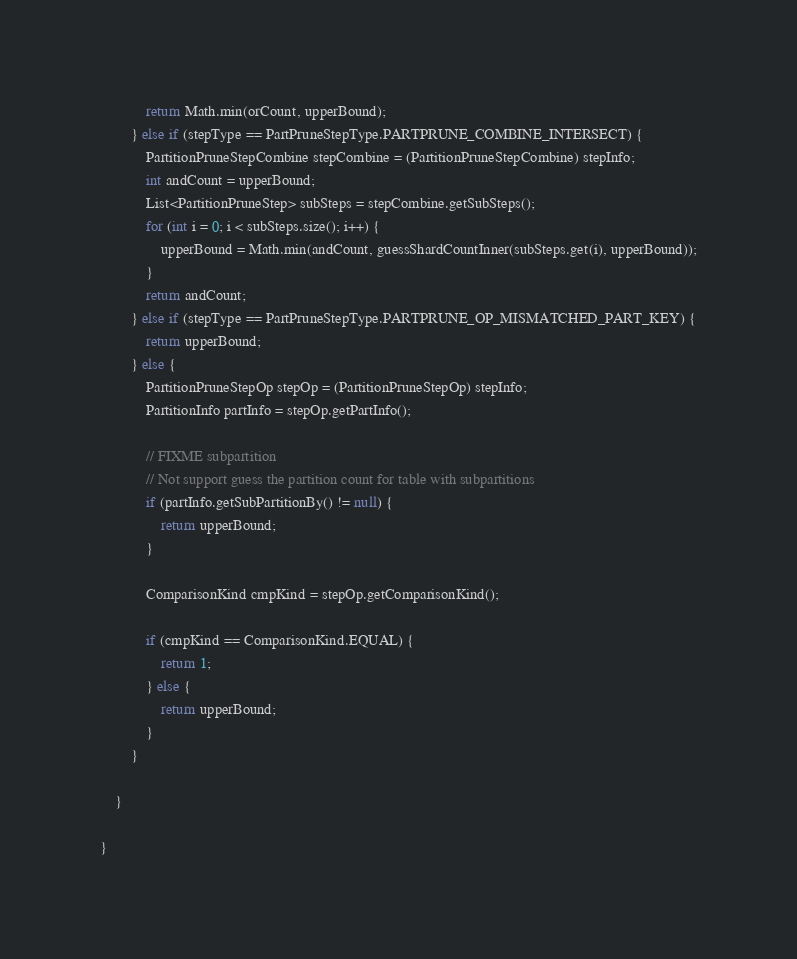Convert code to text. <code><loc_0><loc_0><loc_500><loc_500><_Java_>            return Math.min(orCount, upperBound);
        } else if (stepType == PartPruneStepType.PARTPRUNE_COMBINE_INTERSECT) {
            PartitionPruneStepCombine stepCombine = (PartitionPruneStepCombine) stepInfo;
            int andCount = upperBound;
            List<PartitionPruneStep> subSteps = stepCombine.getSubSteps();
            for (int i = 0; i < subSteps.size(); i++) {
                upperBound = Math.min(andCount, guessShardCountInner(subSteps.get(i), upperBound));
            }
            return andCount;
        } else if (stepType == PartPruneStepType.PARTPRUNE_OP_MISMATCHED_PART_KEY) {
            return upperBound;
        } else {
            PartitionPruneStepOp stepOp = (PartitionPruneStepOp) stepInfo;
            PartitionInfo partInfo = stepOp.getPartInfo();

            // FIXME subpartition
            // Not support guess the partition count for table with subpartitions
            if (partInfo.getSubPartitionBy() != null) {
                return upperBound;
            }

            ComparisonKind cmpKind = stepOp.getComparisonKind();

            if (cmpKind == ComparisonKind.EQUAL) {
                return 1;
            } else {
                return upperBound;
            }
        }

    }

}
</code> 